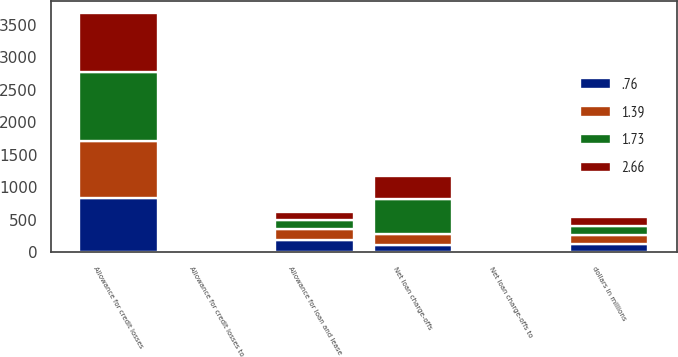Convert chart. <chart><loc_0><loc_0><loc_500><loc_500><stacked_bar_chart><ecel><fcel>dollars in millions<fcel>Net loan charge-offs<fcel>Net loan charge-offs to<fcel>Allowance for loan and lease<fcel>Allowance for credit losses<fcel>Allowance for credit losses to<nl><fcel>0.76<fcel>134.95<fcel>113<fcel>0.2<fcel>190<fcel>830<fcel>1.45<nl><fcel>1.39<fcel>134.95<fcel>168<fcel>0.32<fcel>166.9<fcel>885<fcel>1.63<nl><fcel>2.66<fcel>134.95<fcel>345<fcel>0.69<fcel>131.8<fcel>917<fcel>1.74<nl><fcel>1.73<fcel>134.95<fcel>541<fcel>1.11<fcel>138.1<fcel>1049<fcel>2.12<nl></chart> 